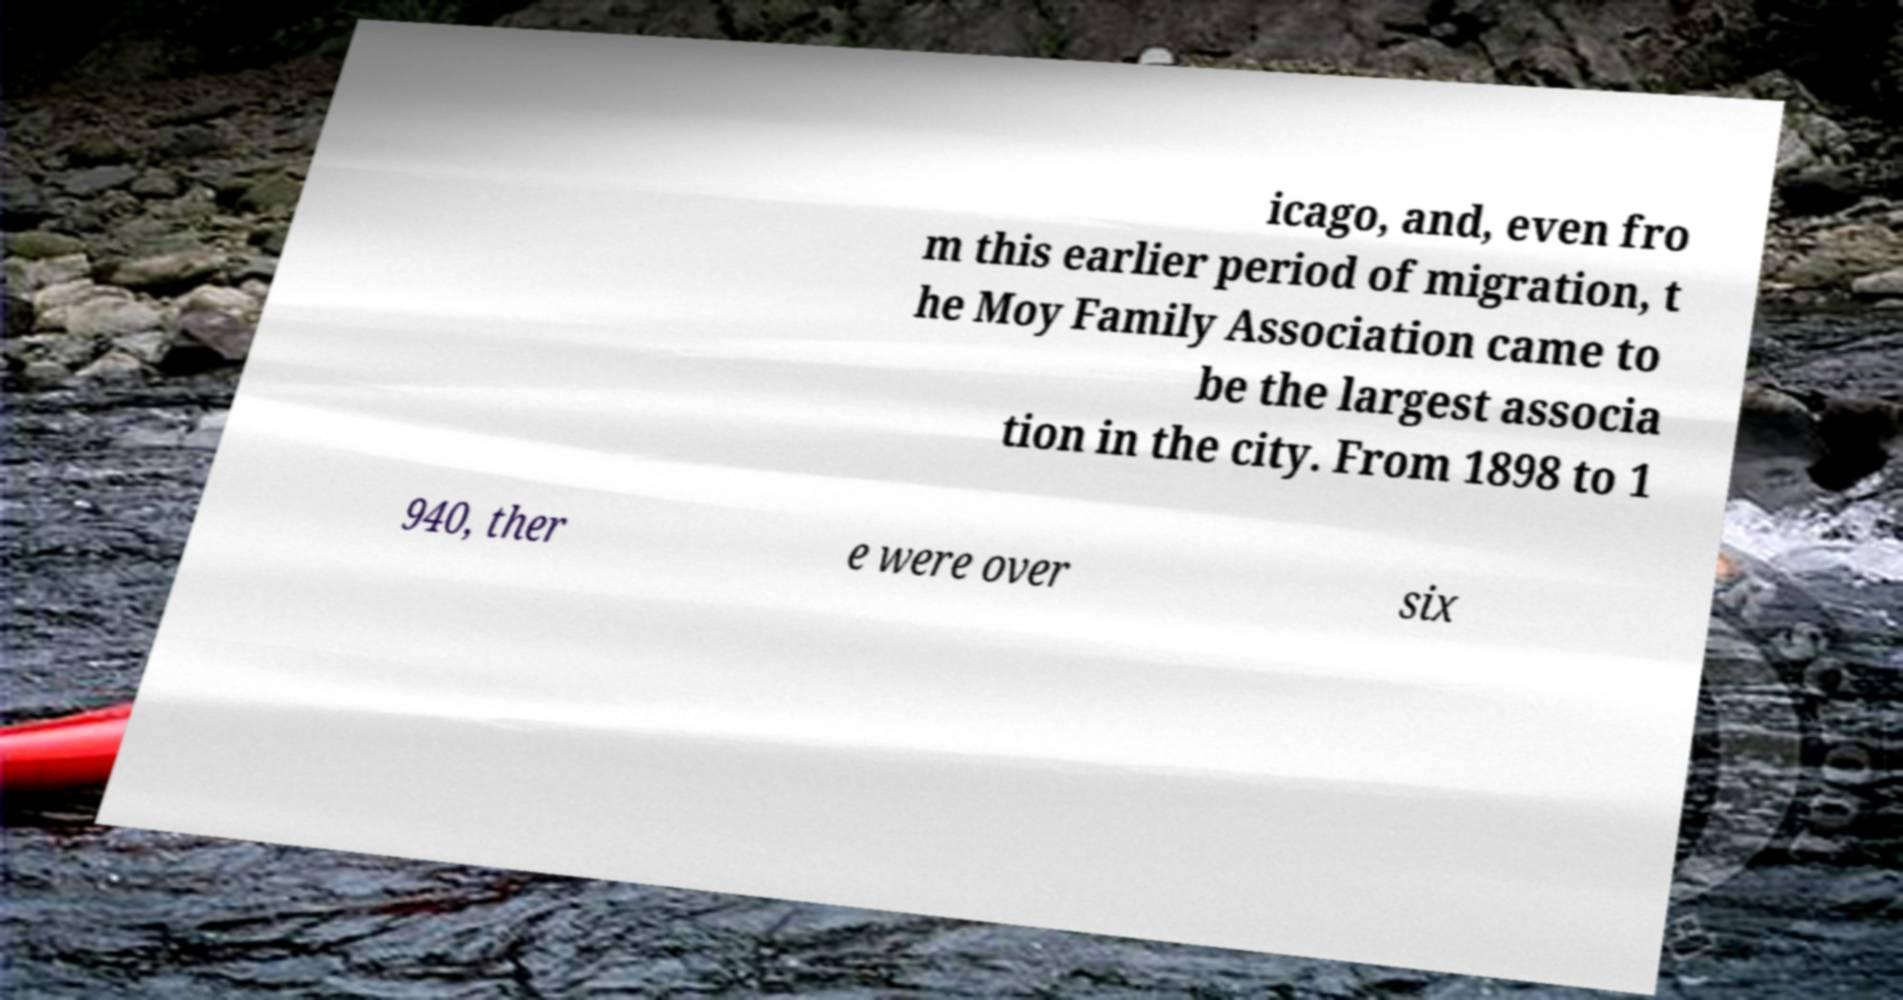Could you extract and type out the text from this image? icago, and, even fro m this earlier period of migration, t he Moy Family Association came to be the largest associa tion in the city. From 1898 to 1 940, ther e were over six 